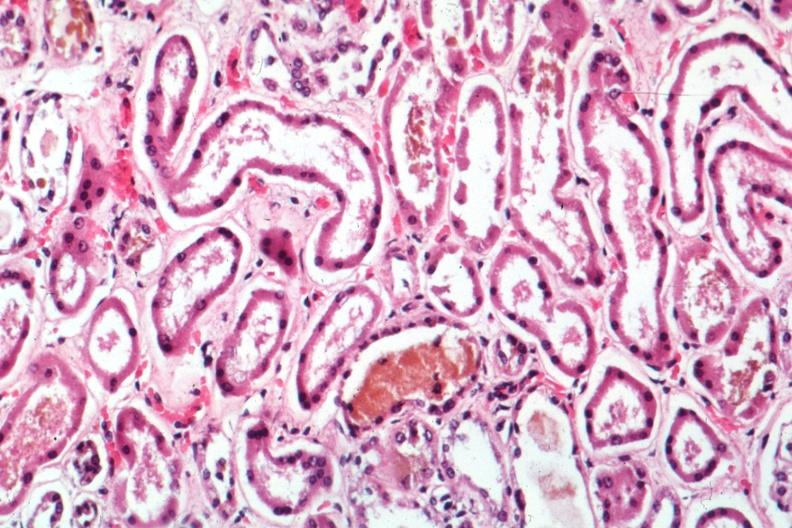where is this?
Answer the question using a single word or phrase. Urinary 